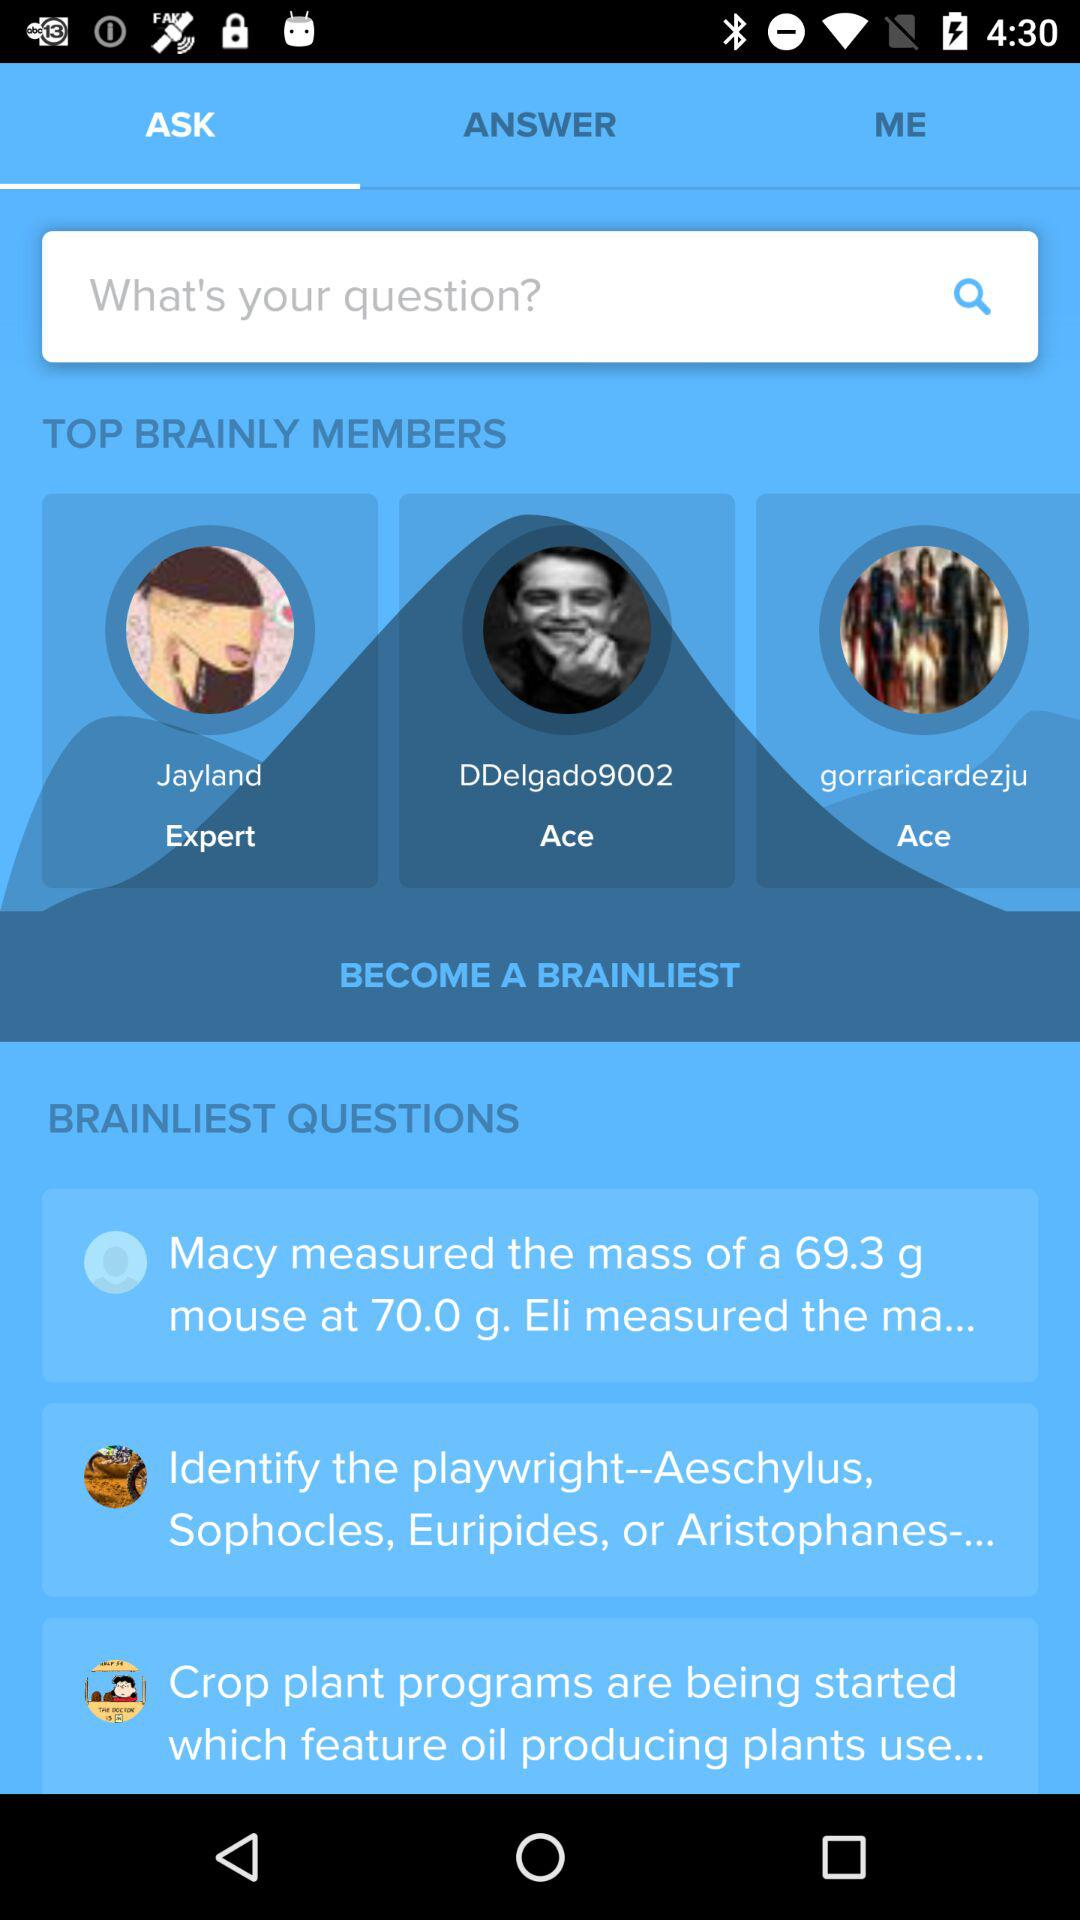What are the top brainly members? The top brainly members are "Jayland", "DDelgado9002" and "gorraricardezju". 